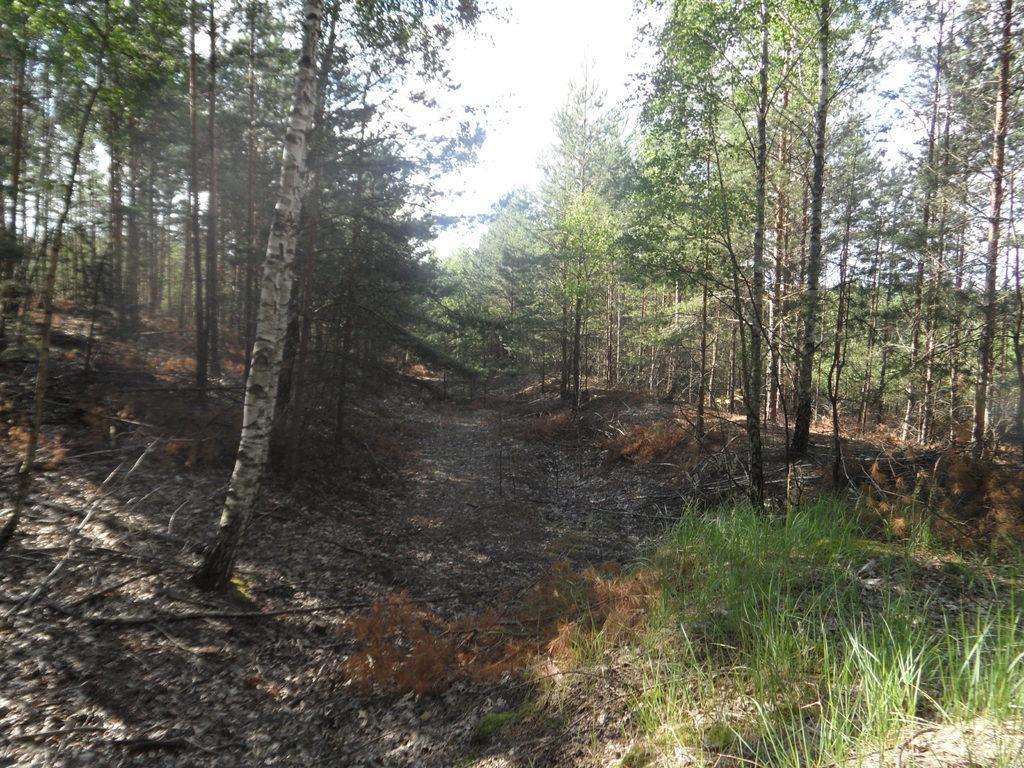In one or two sentences, can you explain what this image depicts? In this image, we can see trees and at the bottom, there is ground and some part of it is covered with grass. 